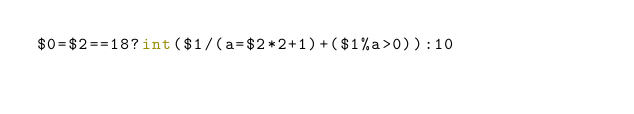Convert code to text. <code><loc_0><loc_0><loc_500><loc_500><_Awk_>$0=$2==18?int($1/(a=$2*2+1)+($1%a>0)):10</code> 